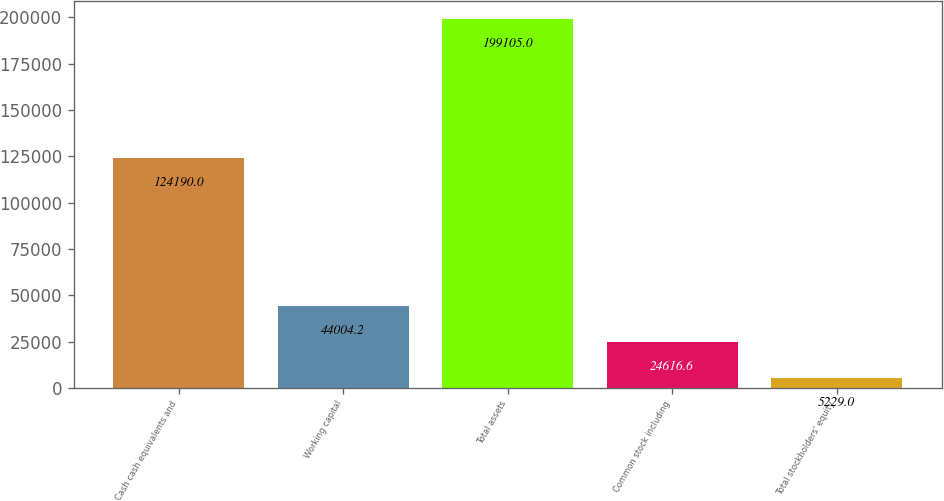Convert chart. <chart><loc_0><loc_0><loc_500><loc_500><bar_chart><fcel>Cash cash equivalents and<fcel>Working capital<fcel>Total assets<fcel>Common stock including<fcel>Total stockholders' equity<nl><fcel>124190<fcel>44004.2<fcel>199105<fcel>24616.6<fcel>5229<nl></chart> 